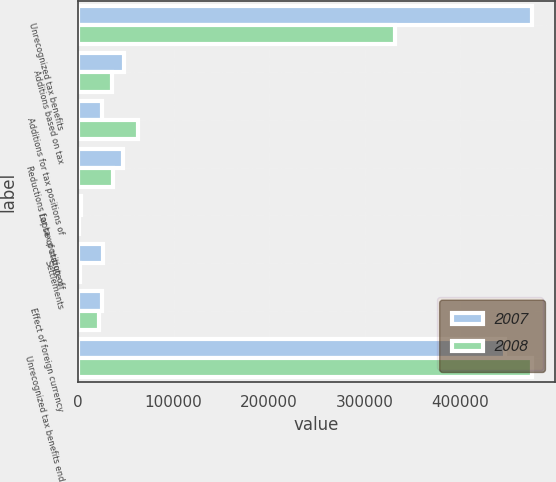<chart> <loc_0><loc_0><loc_500><loc_500><stacked_bar_chart><ecel><fcel>Unrecognized tax benefits<fcel>Additions based on tax<fcel>Additions for tax positions of<fcel>Reductions for tax position of<fcel>Lapse of statute of<fcel>Settlements<fcel>Effect of foreign currency<fcel>Unrecognized tax benefits end<nl><fcel>2007<fcel>475107<fcel>48588<fcel>25095<fcel>47567<fcel>2772<fcel>26384<fcel>25175<fcel>446892<nl><fcel>2008<fcel>331701<fcel>35871<fcel>63315<fcel>37075<fcel>673<fcel>2043<fcel>21889<fcel>475107<nl></chart> 